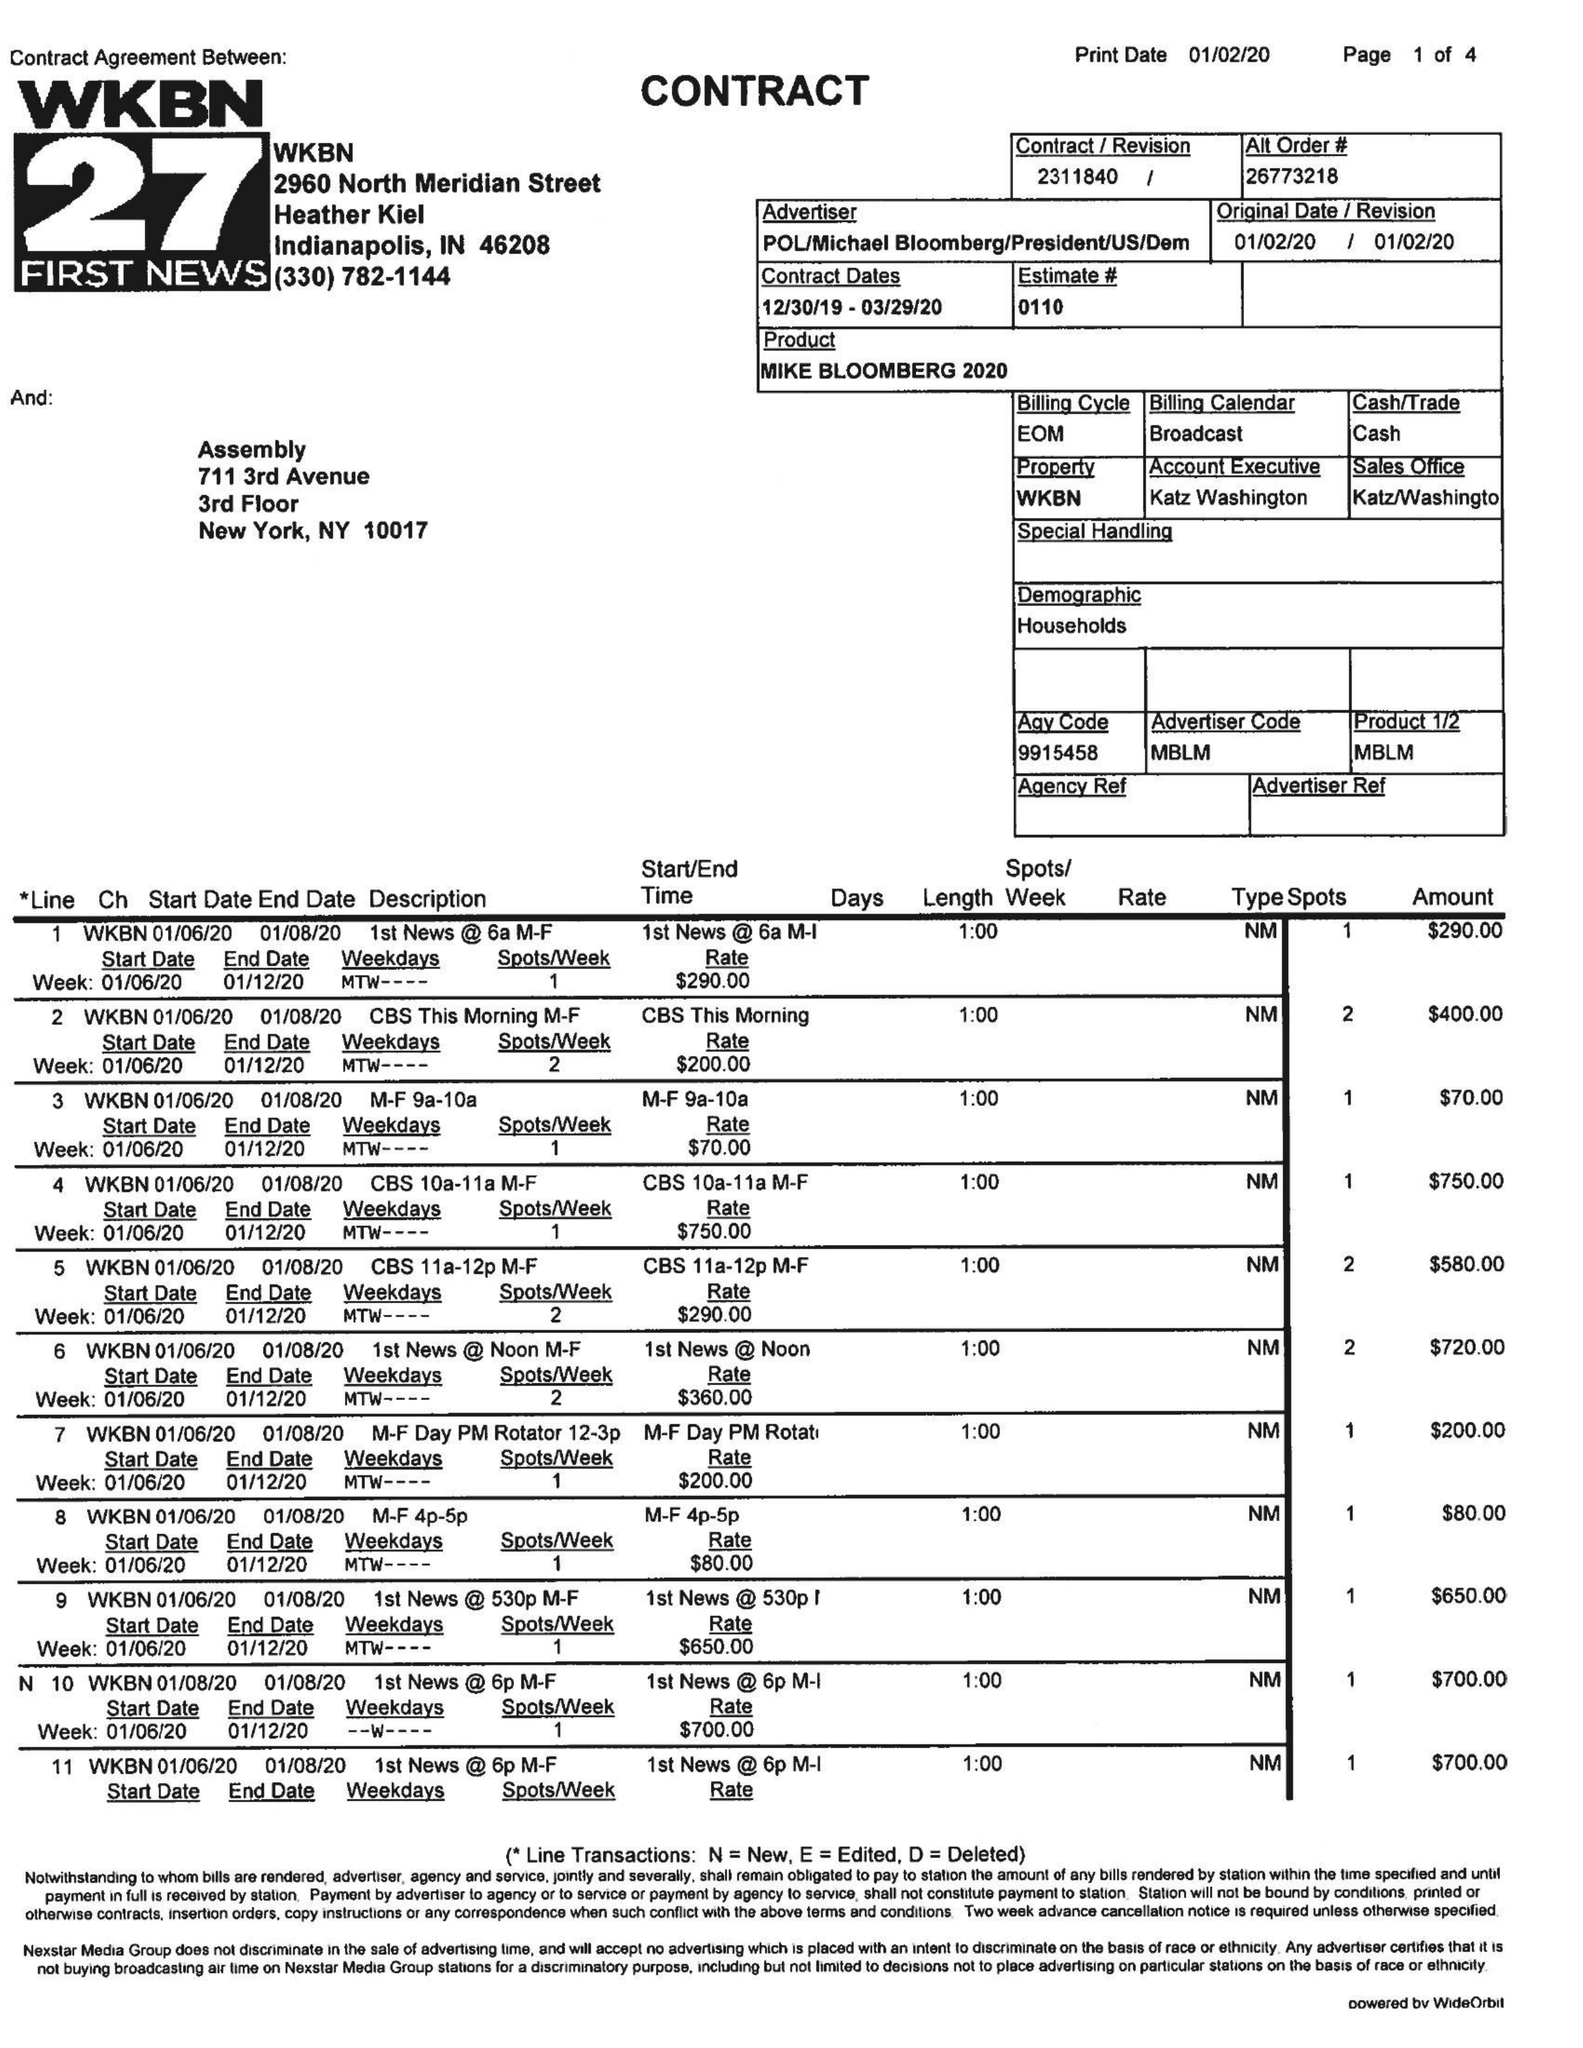What is the value for the advertiser?
Answer the question using a single word or phrase. POL/MICHAELBLOOMBERG/PRESIDENT/US/DEM 